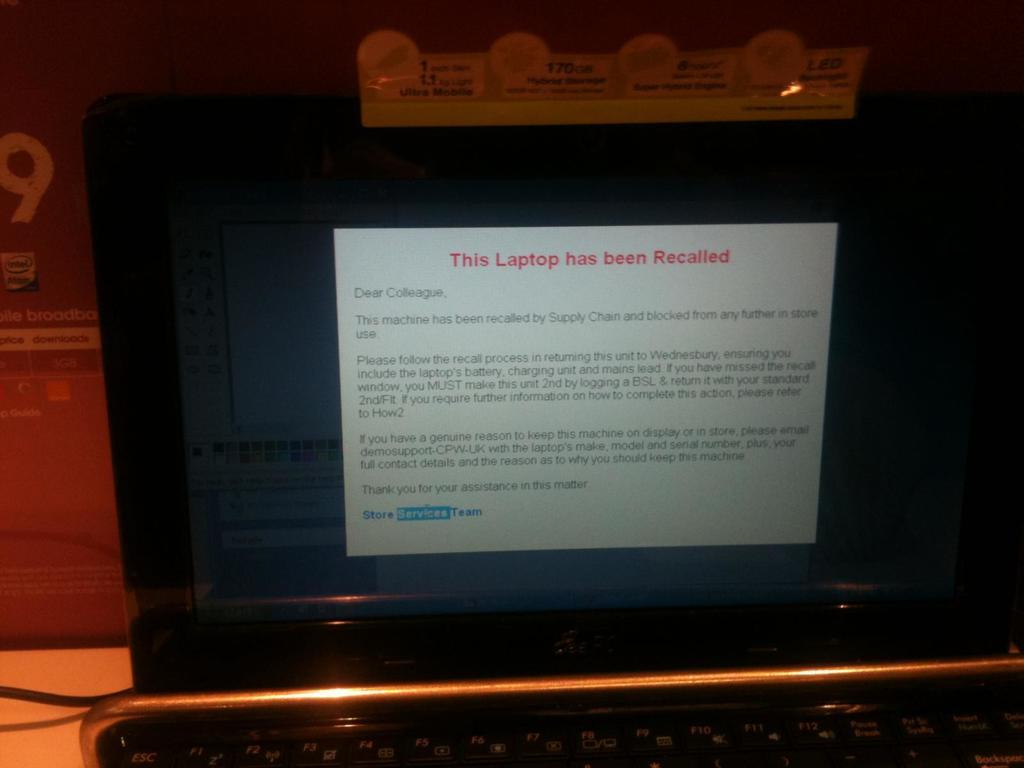<image>
Create a compact narrative representing the image presented. Computer monitor opened that the laptop has been recalled 